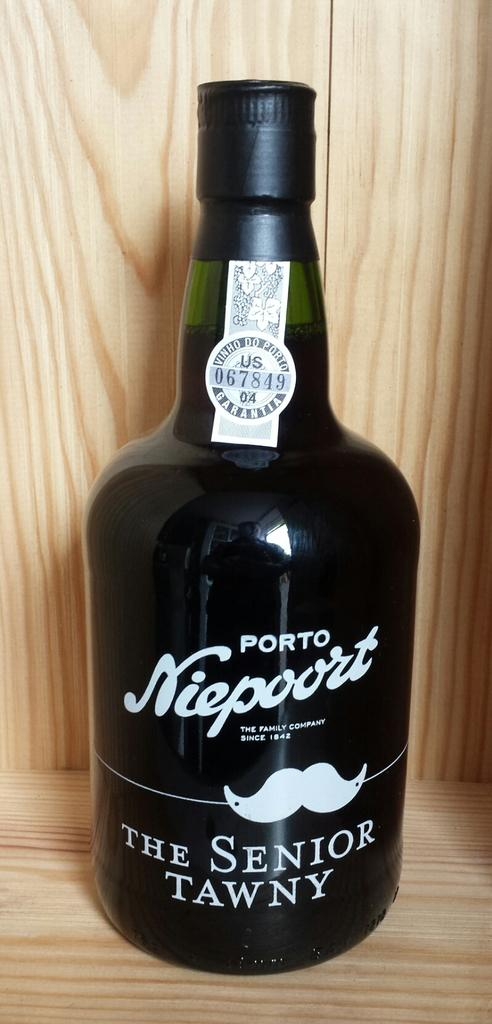<image>
Present a compact description of the photo's key features. A bottle of The Senior Tawny Port stands in a wooden box. 